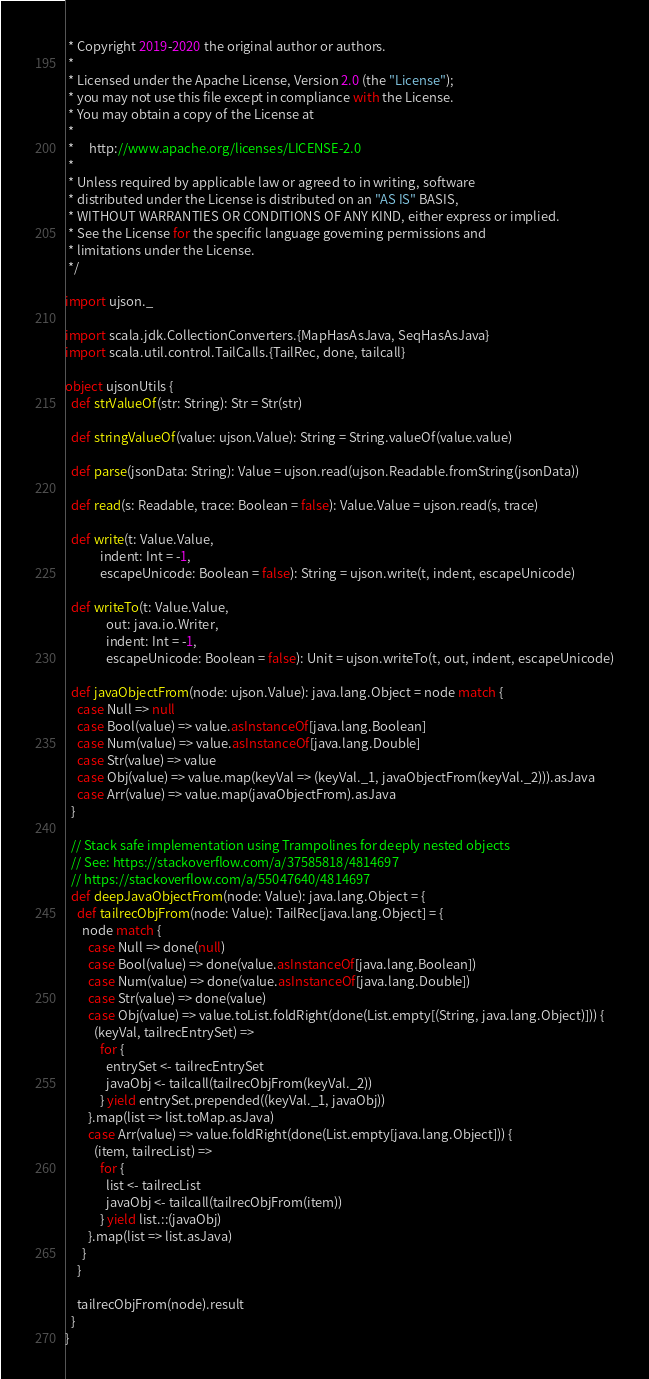<code> <loc_0><loc_0><loc_500><loc_500><_Scala_> * Copyright 2019-2020 the original author or authors.
 *
 * Licensed under the Apache License, Version 2.0 (the "License");
 * you may not use this file except in compliance with the License.
 * You may obtain a copy of the License at
 *
 *     http://www.apache.org/licenses/LICENSE-2.0
 *
 * Unless required by applicable law or agreed to in writing, software
 * distributed under the License is distributed on an "AS IS" BASIS,
 * WITHOUT WARRANTIES OR CONDITIONS OF ANY KIND, either express or implied.
 * See the License for the specific language governing permissions and
 * limitations under the License.
 */

import ujson._

import scala.jdk.CollectionConverters.{MapHasAsJava, SeqHasAsJava}
import scala.util.control.TailCalls.{TailRec, done, tailcall}

object ujsonUtils {
  def strValueOf(str: String): Str = Str(str)

  def stringValueOf(value: ujson.Value): String = String.valueOf(value.value)

  def parse(jsonData: String): Value = ujson.read(ujson.Readable.fromString(jsonData))

  def read(s: Readable, trace: Boolean = false): Value.Value = ujson.read(s, trace)

  def write(t: Value.Value,
            indent: Int = -1,
            escapeUnicode: Boolean = false): String = ujson.write(t, indent, escapeUnicode)

  def writeTo(t: Value.Value,
              out: java.io.Writer,
              indent: Int = -1,
              escapeUnicode: Boolean = false): Unit = ujson.writeTo(t, out, indent, escapeUnicode)

  def javaObjectFrom(node: ujson.Value): java.lang.Object = node match {
    case Null => null
    case Bool(value) => value.asInstanceOf[java.lang.Boolean]
    case Num(value) => value.asInstanceOf[java.lang.Double]
    case Str(value) => value
    case Obj(value) => value.map(keyVal => (keyVal._1, javaObjectFrom(keyVal._2))).asJava
    case Arr(value) => value.map(javaObjectFrom).asJava
  }

  // Stack safe implementation using Trampolines for deeply nested objects
  // See: https://stackoverflow.com/a/37585818/4814697
  // https://stackoverflow.com/a/55047640/4814697
  def deepJavaObjectFrom(node: Value): java.lang.Object = {
    def tailrecObjFrom(node: Value): TailRec[java.lang.Object] = {
      node match {
        case Null => done(null)
        case Bool(value) => done(value.asInstanceOf[java.lang.Boolean])
        case Num(value) => done(value.asInstanceOf[java.lang.Double])
        case Str(value) => done(value)
        case Obj(value) => value.toList.foldRight(done(List.empty[(String, java.lang.Object)])) {
          (keyVal, tailrecEntrySet) =>
            for {
              entrySet <- tailrecEntrySet
              javaObj <- tailcall(tailrecObjFrom(keyVal._2))
            } yield entrySet.prepended((keyVal._1, javaObj))
        }.map(list => list.toMap.asJava)
        case Arr(value) => value.foldRight(done(List.empty[java.lang.Object])) {
          (item, tailrecList) =>
            for {
              list <- tailrecList
              javaObj <- tailcall(tailrecObjFrom(item))
            } yield list.::(javaObj)
        }.map(list => list.asJava)
      }
    }

    tailrecObjFrom(node).result
  }
}
</code> 